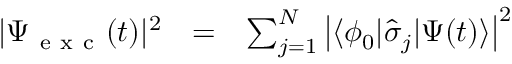<formula> <loc_0><loc_0><loc_500><loc_500>\begin{array} { c c l } { | \Psi _ { e x c } ( t ) | ^ { 2 } } & { = } & { \sum _ { j = 1 } ^ { N } \left | \langle \phi _ { 0 } | \hat { \sigma } _ { j } | \Psi ( t ) \rangle \right | ^ { 2 } } \end{array}</formula> 